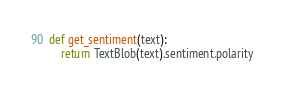<code> <loc_0><loc_0><loc_500><loc_500><_Python_>
def get_sentiment(text):
    return TextBlob(text).sentiment.polarity
</code> 